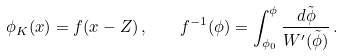<formula> <loc_0><loc_0><loc_500><loc_500>\phi _ { K } ( x ) = f ( x - Z ) \, , \quad f ^ { - 1 } ( \phi ) = \int _ { \phi _ { 0 } } ^ { \phi } \frac { d \tilde { \phi } } { W ^ { \prime } ( \tilde { \phi } ) } \, .</formula> 